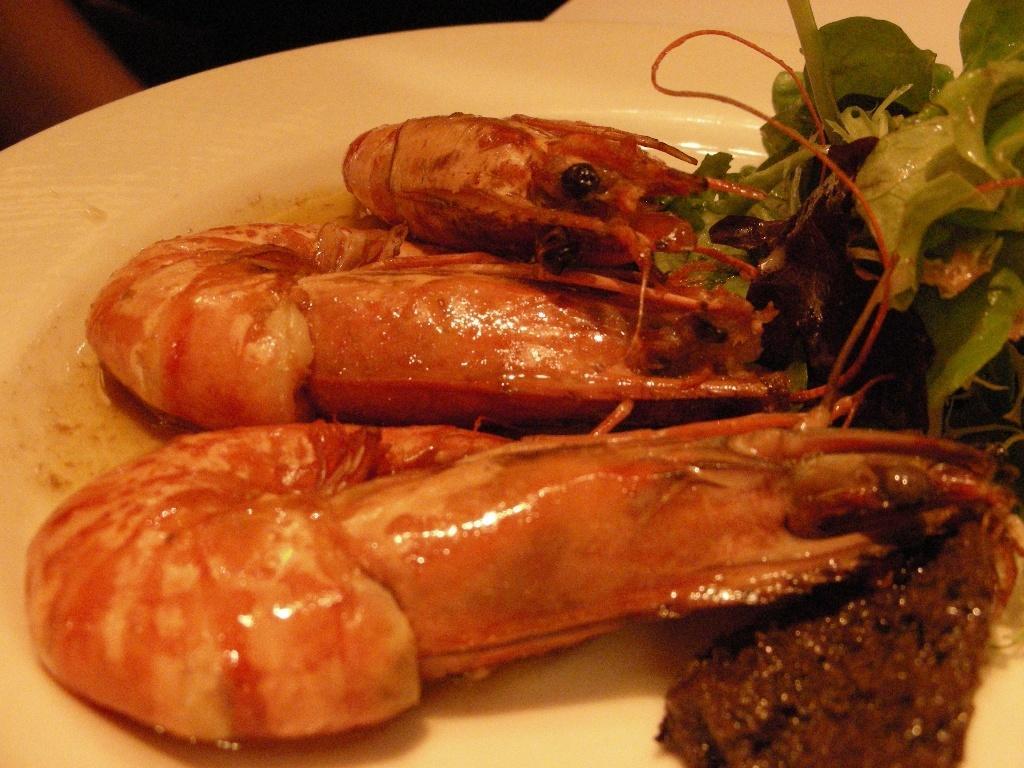In one or two sentences, can you explain what this image depicts? In this image we can see some food containing prawns and some leafy vegetables in a plate. 